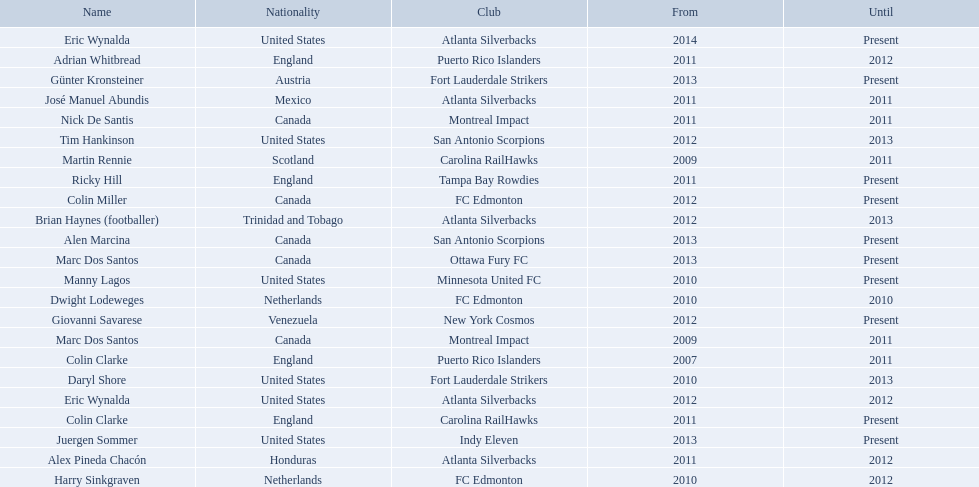What year did marc dos santos start as coach? 2009. Parse the table in full. {'header': ['Name', 'Nationality', 'Club', 'From', 'Until'], 'rows': [['Eric Wynalda', 'United States', 'Atlanta Silverbacks', '2014', 'Present'], ['Adrian Whitbread', 'England', 'Puerto Rico Islanders', '2011', '2012'], ['Günter Kronsteiner', 'Austria', 'Fort Lauderdale Strikers', '2013', 'Present'], ['José Manuel Abundis', 'Mexico', 'Atlanta Silverbacks', '2011', '2011'], ['Nick De Santis', 'Canada', 'Montreal Impact', '2011', '2011'], ['Tim Hankinson', 'United States', 'San Antonio Scorpions', '2012', '2013'], ['Martin Rennie', 'Scotland', 'Carolina RailHawks', '2009', '2011'], ['Ricky Hill', 'England', 'Tampa Bay Rowdies', '2011', 'Present'], ['Colin Miller', 'Canada', 'FC Edmonton', '2012', 'Present'], ['Brian Haynes (footballer)', 'Trinidad and Tobago', 'Atlanta Silverbacks', '2012', '2013'], ['Alen Marcina', 'Canada', 'San Antonio Scorpions', '2013', 'Present'], ['Marc Dos Santos', 'Canada', 'Ottawa Fury FC', '2013', 'Present'], ['Manny Lagos', 'United States', 'Minnesota United FC', '2010', 'Present'], ['Dwight Lodeweges', 'Netherlands', 'FC Edmonton', '2010', '2010'], ['Giovanni Savarese', 'Venezuela', 'New York Cosmos', '2012', 'Present'], ['Marc Dos Santos', 'Canada', 'Montreal Impact', '2009', '2011'], ['Colin Clarke', 'England', 'Puerto Rico Islanders', '2007', '2011'], ['Daryl Shore', 'United States', 'Fort Lauderdale Strikers', '2010', '2013'], ['Eric Wynalda', 'United States', 'Atlanta Silverbacks', '2012', '2012'], ['Colin Clarke', 'England', 'Carolina RailHawks', '2011', 'Present'], ['Juergen Sommer', 'United States', 'Indy Eleven', '2013', 'Present'], ['Alex Pineda Chacón', 'Honduras', 'Atlanta Silverbacks', '2011', '2012'], ['Harry Sinkgraven', 'Netherlands', 'FC Edmonton', '2010', '2012']]} Besides marc dos santos, what other coach started in 2009? Martin Rennie. 